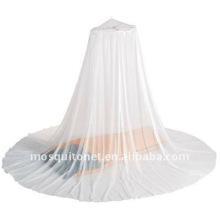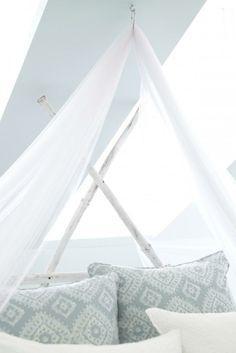The first image is the image on the left, the second image is the image on the right. For the images shown, is this caption "There is exactly one pillow on the bed in one of the images." true? Answer yes or no. No. 